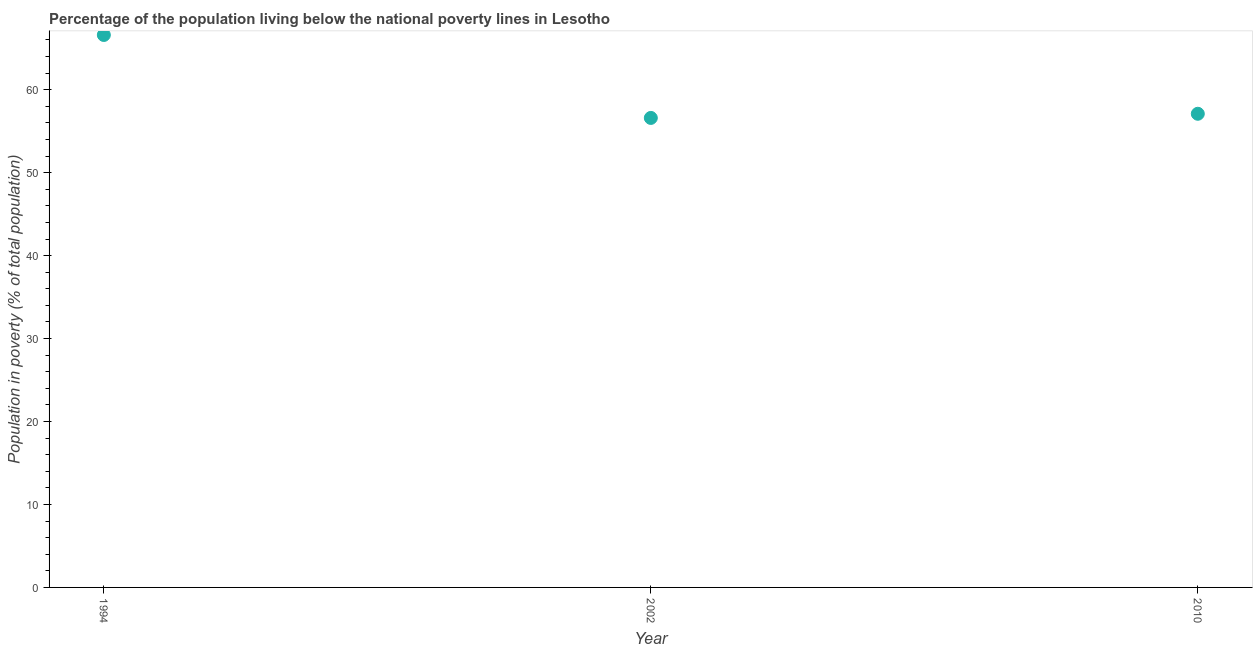What is the percentage of population living below poverty line in 1994?
Offer a terse response. 66.6. Across all years, what is the maximum percentage of population living below poverty line?
Your answer should be very brief. 66.6. Across all years, what is the minimum percentage of population living below poverty line?
Give a very brief answer. 56.6. In which year was the percentage of population living below poverty line maximum?
Offer a very short reply. 1994. In which year was the percentage of population living below poverty line minimum?
Your response must be concise. 2002. What is the sum of the percentage of population living below poverty line?
Provide a succinct answer. 180.3. What is the difference between the percentage of population living below poverty line in 1994 and 2010?
Provide a succinct answer. 9.5. What is the average percentage of population living below poverty line per year?
Make the answer very short. 60.1. What is the median percentage of population living below poverty line?
Offer a terse response. 57.1. What is the ratio of the percentage of population living below poverty line in 2002 to that in 2010?
Keep it short and to the point. 0.99. Is the percentage of population living below poverty line in 2002 less than that in 2010?
Keep it short and to the point. Yes. What is the difference between the highest and the second highest percentage of population living below poverty line?
Provide a succinct answer. 9.5. What is the difference between the highest and the lowest percentage of population living below poverty line?
Make the answer very short. 10. In how many years, is the percentage of population living below poverty line greater than the average percentage of population living below poverty line taken over all years?
Your answer should be very brief. 1. Does the percentage of population living below poverty line monotonically increase over the years?
Give a very brief answer. No. How many years are there in the graph?
Provide a short and direct response. 3. What is the difference between two consecutive major ticks on the Y-axis?
Your answer should be compact. 10. Does the graph contain grids?
Offer a very short reply. No. What is the title of the graph?
Provide a short and direct response. Percentage of the population living below the national poverty lines in Lesotho. What is the label or title of the Y-axis?
Offer a very short reply. Population in poverty (% of total population). What is the Population in poverty (% of total population) in 1994?
Give a very brief answer. 66.6. What is the Population in poverty (% of total population) in 2002?
Your response must be concise. 56.6. What is the Population in poverty (% of total population) in 2010?
Ensure brevity in your answer.  57.1. What is the difference between the Population in poverty (% of total population) in 1994 and 2002?
Your response must be concise. 10. What is the ratio of the Population in poverty (% of total population) in 1994 to that in 2002?
Your response must be concise. 1.18. What is the ratio of the Population in poverty (% of total population) in 1994 to that in 2010?
Give a very brief answer. 1.17. What is the ratio of the Population in poverty (% of total population) in 2002 to that in 2010?
Provide a short and direct response. 0.99. 